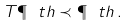Convert formula to latex. <formula><loc_0><loc_0><loc_500><loc_500>T \P _ { \ } t h \prec \P _ { \ } t h \, .</formula> 